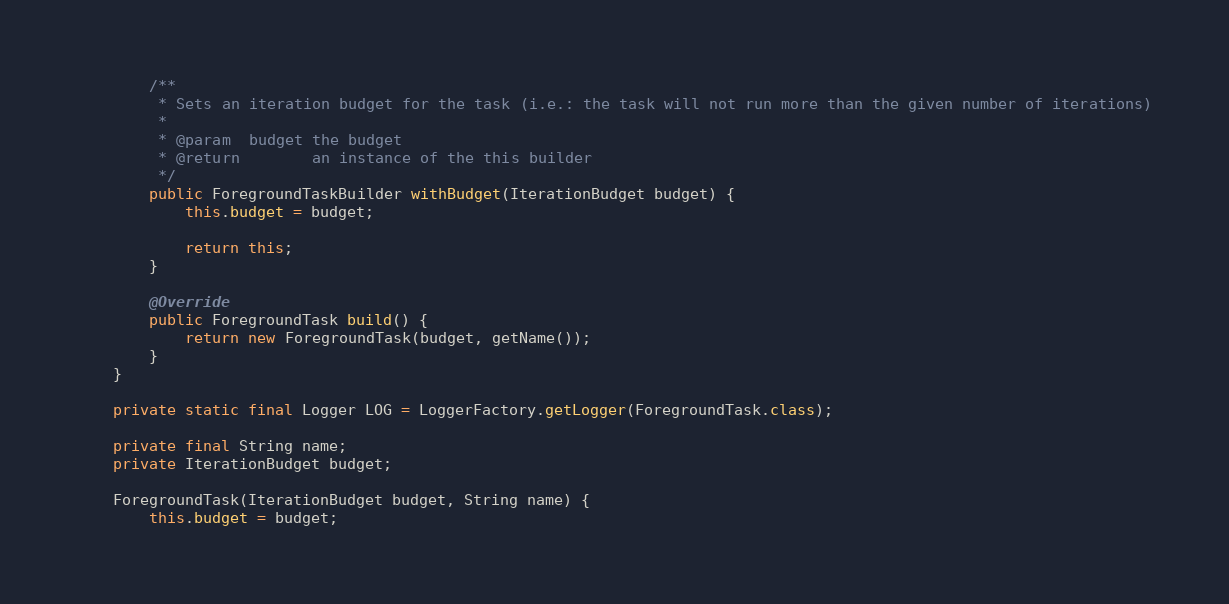<code> <loc_0><loc_0><loc_500><loc_500><_Java_>        /**
         * Sets an iteration budget for the task (i.e.: the task will not run more than the given number of iterations)
         * 
         * @param  budget the budget
         * @return        an instance of the this builder
         */
        public ForegroundTaskBuilder withBudget(IterationBudget budget) {
            this.budget = budget;

            return this;
        }

        @Override
        public ForegroundTask build() {
            return new ForegroundTask(budget, getName());
        }
    }

    private static final Logger LOG = LoggerFactory.getLogger(ForegroundTask.class);

    private final String name;
    private IterationBudget budget;

    ForegroundTask(IterationBudget budget, String name) {
        this.budget = budget;</code> 